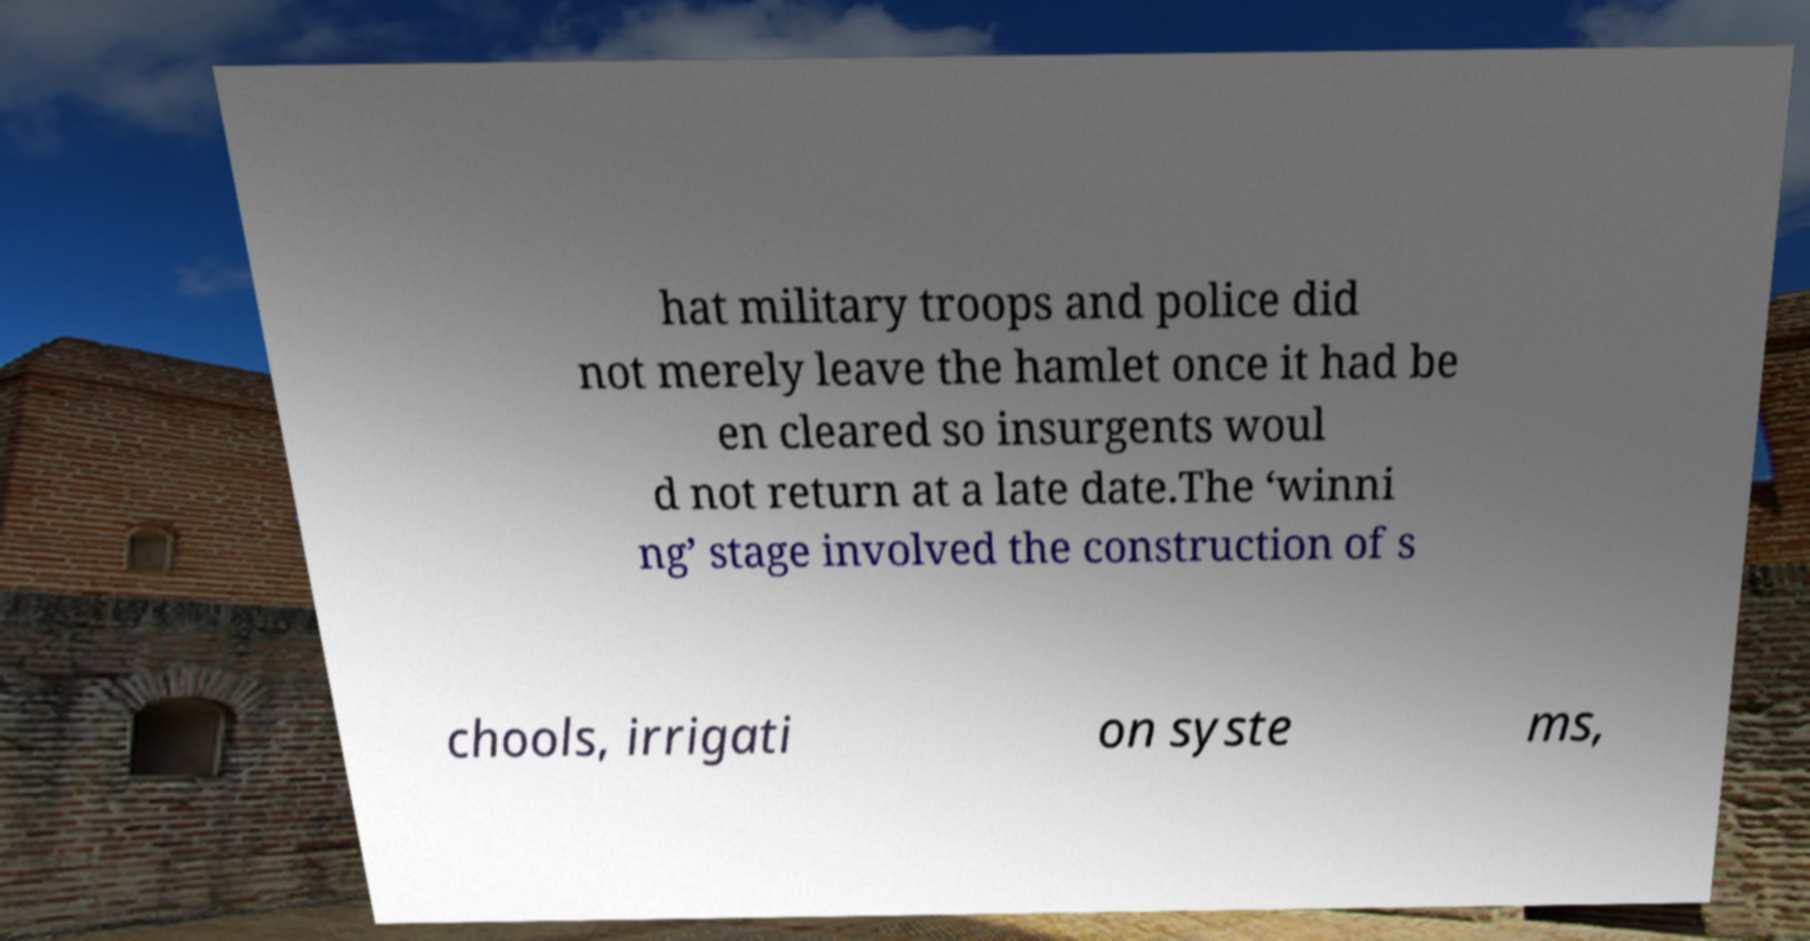Can you accurately transcribe the text from the provided image for me? hat military troops and police did not merely leave the hamlet once it had be en cleared so insurgents woul d not return at a late date.The ‘winni ng’ stage involved the construction of s chools, irrigati on syste ms, 